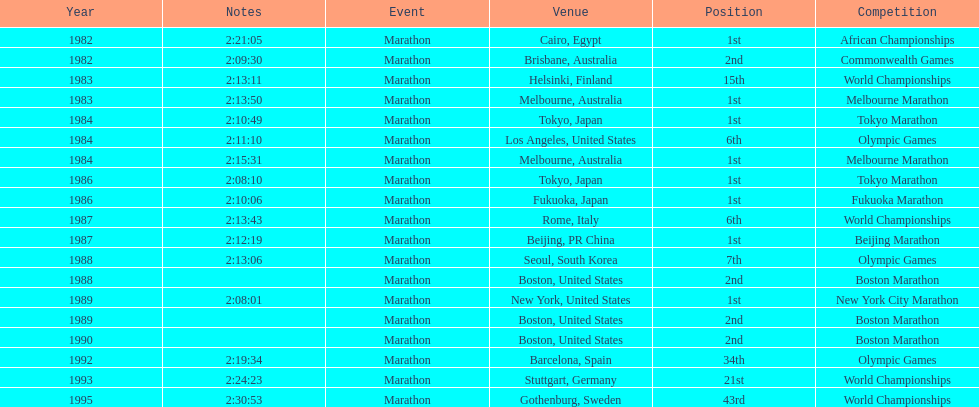How many times in total did ikangaa run the marathon in the olympic games? 3. 